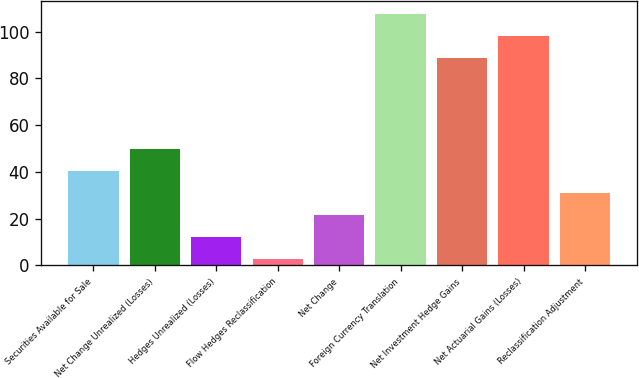Convert chart. <chart><loc_0><loc_0><loc_500><loc_500><bar_chart><fcel>Securities Available for Sale<fcel>Net Change Unrealized (Losses)<fcel>Hedges Unrealized (Losses)<fcel>Flow Hedges Reclassification<fcel>Net Change<fcel>Foreign Currency Translation<fcel>Net Investment Hedge Gains<fcel>Net Actuarial Gains (Losses)<fcel>Reclassification Adjustment<nl><fcel>40.3<fcel>49.75<fcel>11.95<fcel>2.5<fcel>21.4<fcel>107.7<fcel>88.8<fcel>98.25<fcel>30.85<nl></chart> 